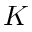Convert formula to latex. <formula><loc_0><loc_0><loc_500><loc_500>K</formula> 